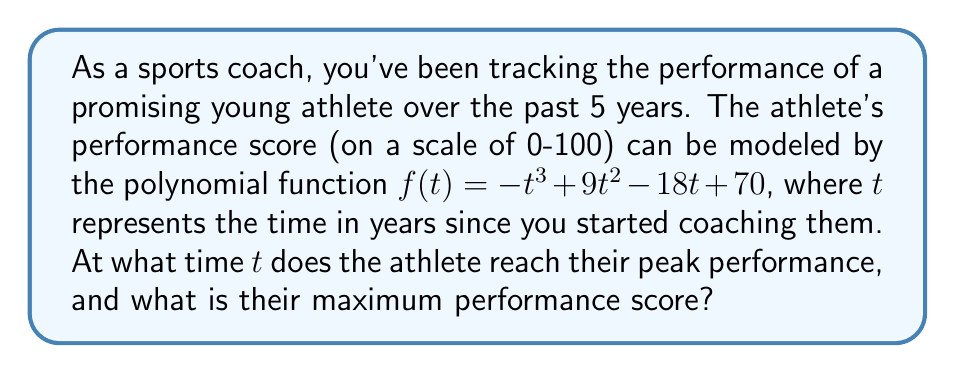Help me with this question. To find the peak performance, we need to determine the maximum point of the polynomial function. This can be done by following these steps:

1) Find the derivative of the function:
   $f'(t) = -3t^2 + 18t - 18$

2) Set the derivative equal to zero to find critical points:
   $-3t^2 + 18t - 18 = 0$

3) Solve the quadratic equation:
   $-3(t^2 - 6t + 6) = 0$
   $t^2 - 6t + 6 = 0$
   $(t - 3)^2 = 3$
   $t - 3 = \pm\sqrt{3}$
   $t = 3 \pm \sqrt{3}$

4) The two critical points are:
   $t_1 = 3 + \sqrt{3} \approx 4.73$ years
   $t_2 = 3 - \sqrt{3} \approx 1.27$ years

5) To determine which point gives the maximum, we can use the second derivative test or simply evaluate the function at both points:

   $f(3 + \sqrt{3}) = -(3 + \sqrt{3})^3 + 9(3 + \sqrt{3})^2 - 18(3 + \sqrt{3}) + 70 \approx 84.23$
   $f(3 - \sqrt{3}) = -(3 - \sqrt{3})^3 + 9(3 - \sqrt{3})^2 - 18(3 - \sqrt{3}) + 70 \approx 79.77$

6) The maximum occurs at $t = 3 + \sqrt{3} \approx 4.73$ years, with a performance score of approximately 84.23.
Answer: $t \approx 4.73$ years, maximum score $\approx 84.23$ 